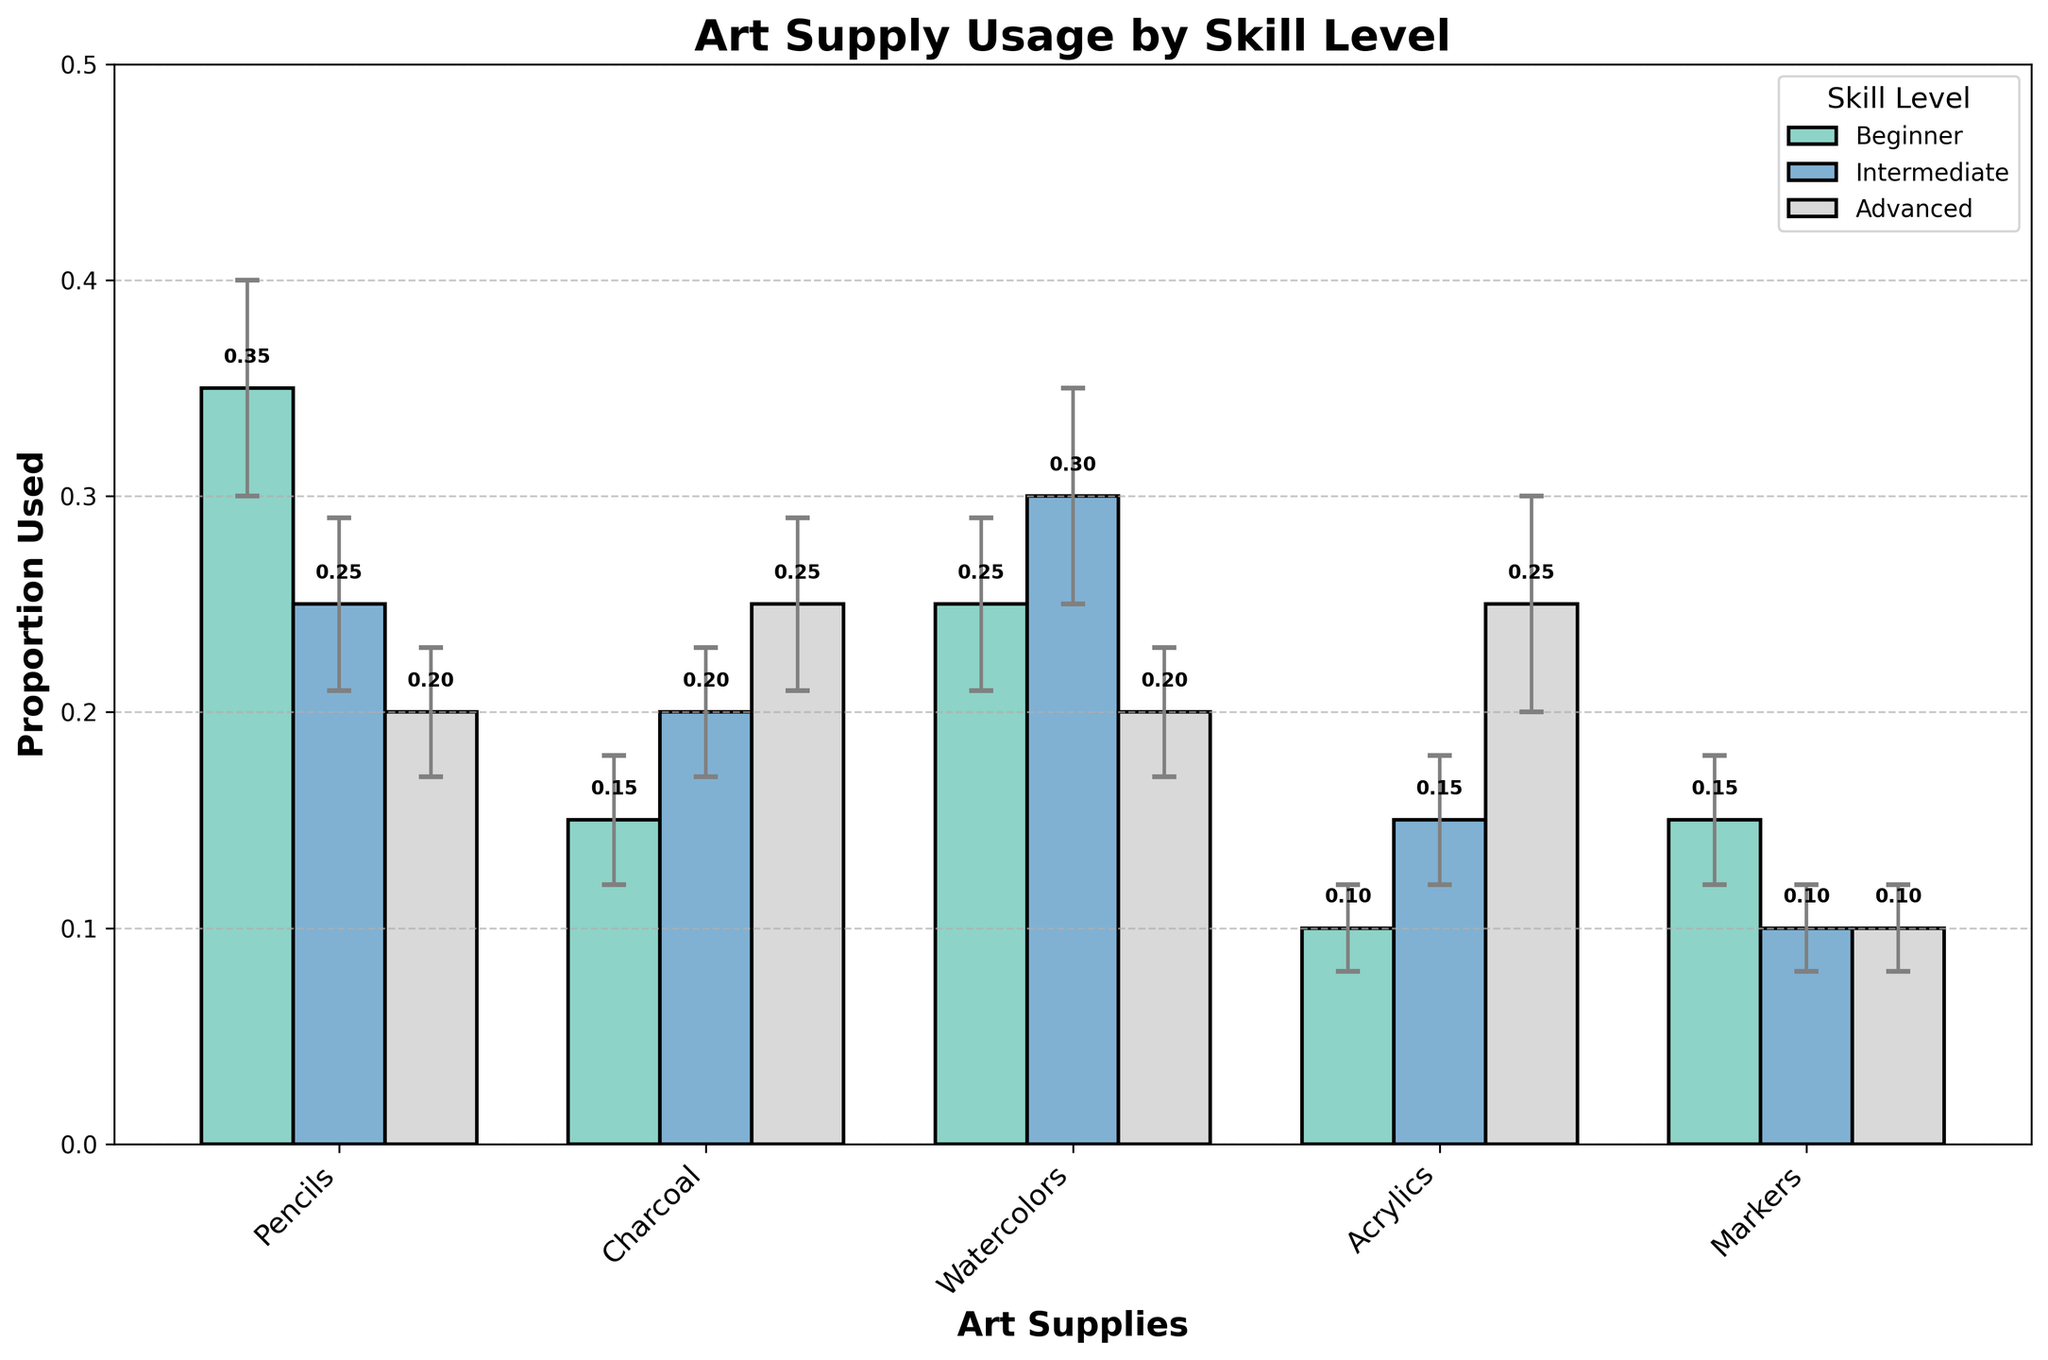What is the most commonly used art supply by beginners? According to the chart, the tallest bar for beginners corresponds to pencils, with a proportion of 0.35.
Answer: Pencils Which art supply shows the most increase in usage from beginner to intermediate level? Comparing the bars for each art supply between beginner and intermediate levels, watercolors show the largest increase from 0.25 to 0.30.
Answer: Watercolors Which skill level uses acrylics most frequently? The tallest bar for acrylics appears under the advanced skill level, with a proportion of 0.25.
Answer: Advanced What is the total proportion of art supplies used by intermediate artists? Summing the intermediate level proportions: 0.25 (Pencils) + 0.20 (Charcoal) + 0.30 (Watercolors) + 0.15 (Acrylics) + 0.10 (Markers) = 1.00.
Answer: 1.00 How does the usage of pencils compare between beginners and advanced artists? For beginners, the proportion used is 0.35, and for advanced, it is 0.20. Therefore, beginners use pencils more than advanced artists.
Answer: Beginners use more Which art supply has the smallest standard error for advanced artists? The smaller vertical error bars indicate the smallest standard error, which is for Markers with a standard error of 0.02.
Answer: Markers What is the difference in charcoal usage between advanced and intermediate artists? The proportion for advanced artists using charcoal is 0.25, and for intermediate artists, it is 0.20. The difference is 0.25 - 0.20 = 0.05.
Answer: 0.05 Which art supply has the most consistent usage across all skill levels? Looking at the height of the bars and their error bars across skill levels, markers appear to have the most consistent usage, with proportions around 0.10 to 0.15.
Answer: Markers 